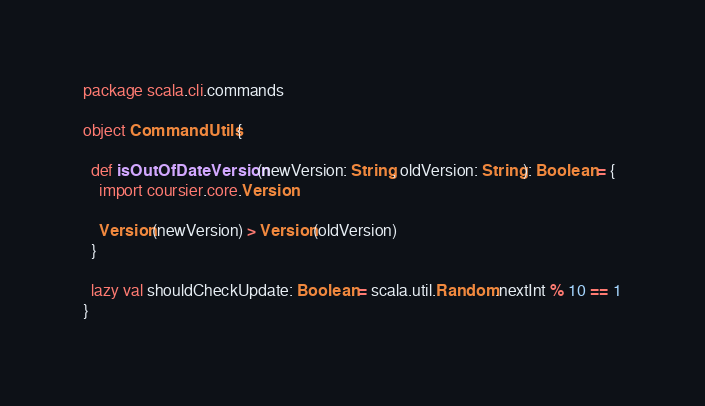Convert code to text. <code><loc_0><loc_0><loc_500><loc_500><_Scala_>package scala.cli.commands

object CommandUtils {

  def isOutOfDateVersion(newVersion: String, oldVersion: String): Boolean = {
    import coursier.core.Version

    Version(newVersion) > Version(oldVersion)
  }

  lazy val shouldCheckUpdate: Boolean = scala.util.Random.nextInt % 10 == 1
}
</code> 